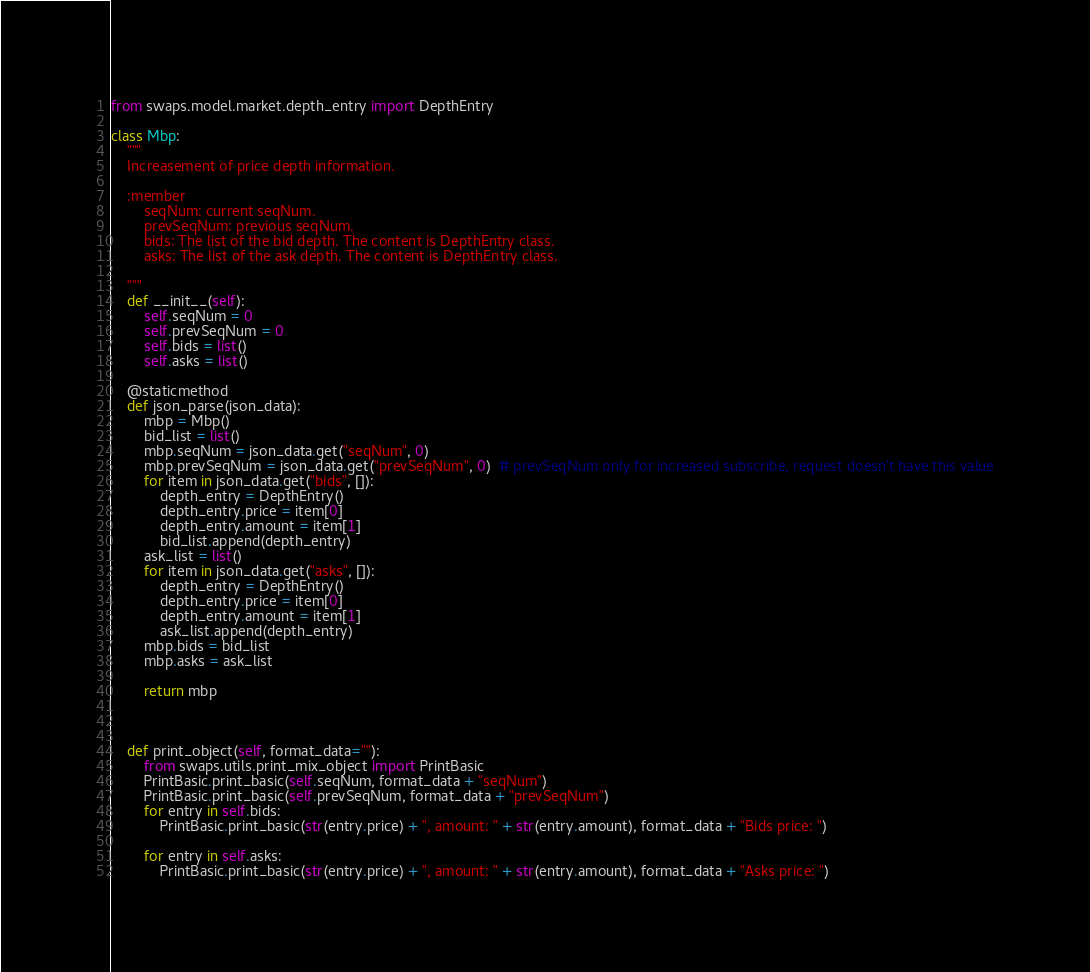<code> <loc_0><loc_0><loc_500><loc_500><_Python_>

from swaps.model.market.depth_entry import DepthEntry

class Mbp:
    """
    Increasement of price depth information.

    :member
        seqNum: current seqNum.
        prevSeqNum: previous seqNum.
        bids: The list of the bid depth. The content is DepthEntry class.
        asks: The list of the ask depth. The content is DepthEntry class.

    """
    def __init__(self):
        self.seqNum = 0
        self.prevSeqNum = 0
        self.bids = list()
        self.asks = list()

    @staticmethod
    def json_parse(json_data):
        mbp = Mbp()
        bid_list = list()
        mbp.seqNum = json_data.get("seqNum", 0)
        mbp.prevSeqNum = json_data.get("prevSeqNum", 0)  # prevSeqNum only for increased subscribe, request doesn't have this value
        for item in json_data.get("bids", []):
            depth_entry = DepthEntry()
            depth_entry.price = item[0]
            depth_entry.amount = item[1]
            bid_list.append(depth_entry)
        ask_list = list()
        for item in json_data.get("asks", []):
            depth_entry = DepthEntry()
            depth_entry.price = item[0]
            depth_entry.amount = item[1]
            ask_list.append(depth_entry)
        mbp.bids = bid_list
        mbp.asks = ask_list

        return mbp



    def print_object(self, format_data=""):
        from swaps.utils.print_mix_object import PrintBasic
        PrintBasic.print_basic(self.seqNum, format_data + "seqNum")
        PrintBasic.print_basic(self.prevSeqNum, format_data + "prevSeqNum")
        for entry in self.bids:
            PrintBasic.print_basic(str(entry.price) + ", amount: " + str(entry.amount), format_data + "Bids price: ")

        for entry in self.asks:
            PrintBasic.print_basic(str(entry.price) + ", amount: " + str(entry.amount), format_data + "Asks price: ")
</code> 